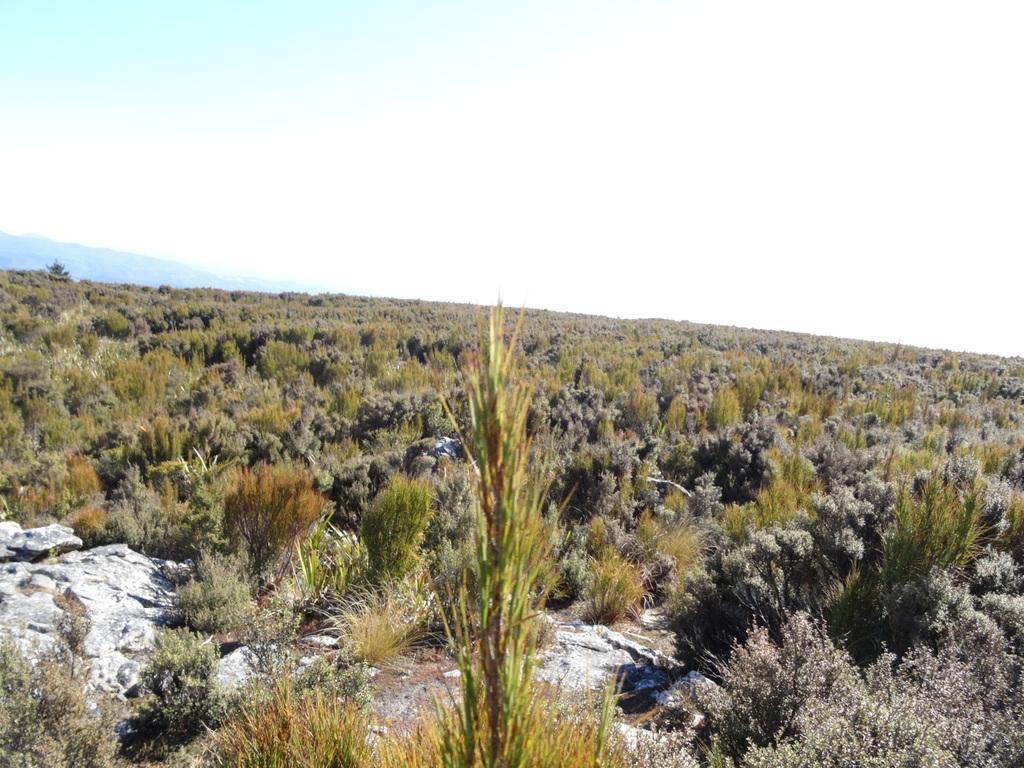Can you describe this image briefly? This picture is clicked outside the city. In the center we can see the plants and grass. In the background there is a sky and some other objects seems to be the hills. 